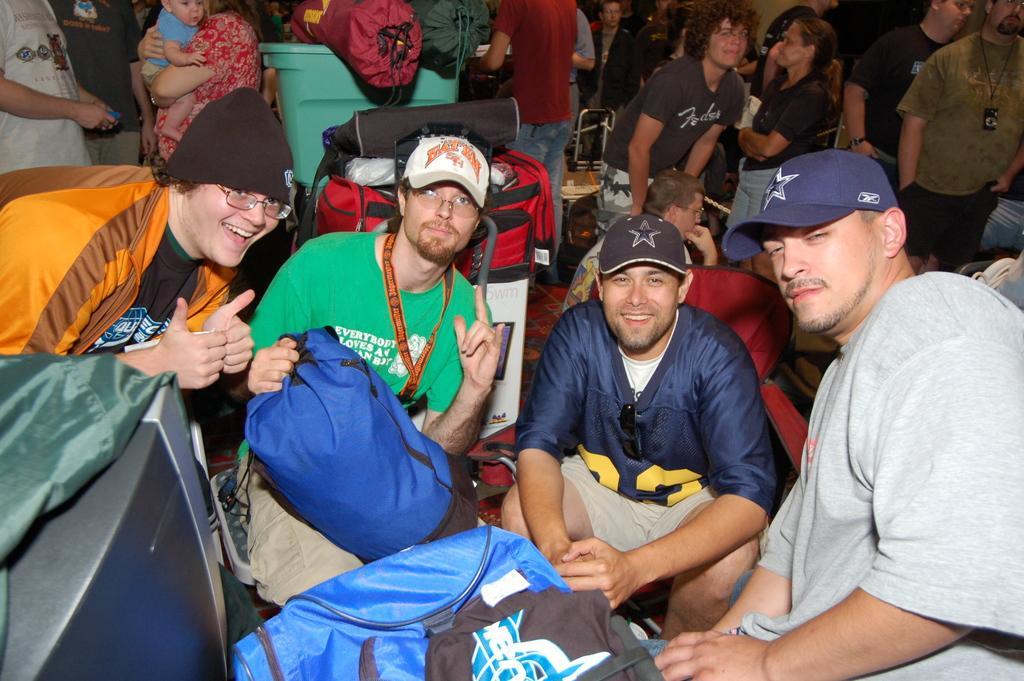Describe this image in one or two sentences. In the center of the image we can see three men sitting. On the left there is a man. In the background we can see people, luggages and trolleys. 